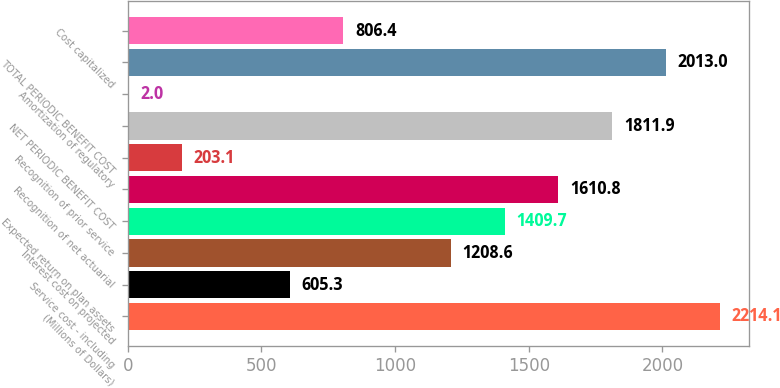Convert chart to OTSL. <chart><loc_0><loc_0><loc_500><loc_500><bar_chart><fcel>(Millions of Dollars)<fcel>Service cost - including<fcel>Interest cost on projected<fcel>Expected return on plan assets<fcel>Recognition of net actuarial<fcel>Recognition of prior service<fcel>NET PERIODIC BENEFIT COST<fcel>Amortization of regulatory<fcel>TOTAL PERIODIC BENEFIT COST<fcel>Cost capitalized<nl><fcel>2214.1<fcel>605.3<fcel>1208.6<fcel>1409.7<fcel>1610.8<fcel>203.1<fcel>1811.9<fcel>2<fcel>2013<fcel>806.4<nl></chart> 